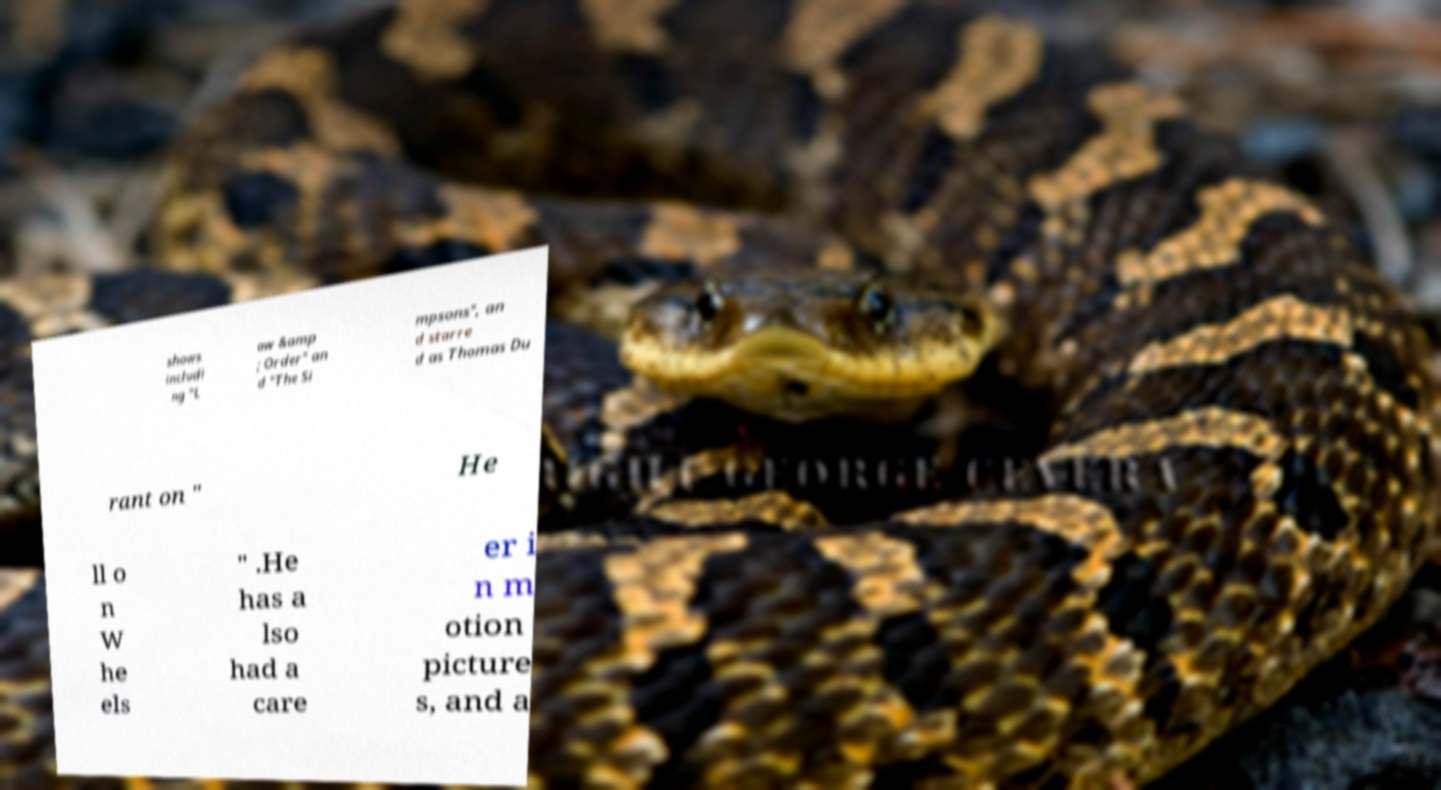Please identify and transcribe the text found in this image. shows includi ng "L aw &amp ; Order" an d "The Si mpsons", an d starre d as Thomas Du rant on " He ll o n W he els " .He has a lso had a care er i n m otion picture s, and a 